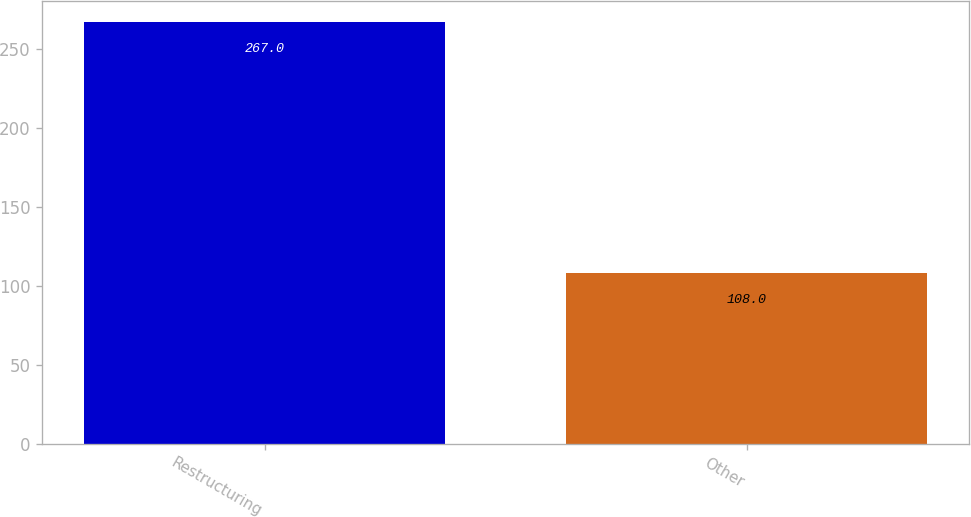Convert chart to OTSL. <chart><loc_0><loc_0><loc_500><loc_500><bar_chart><fcel>Restructuring<fcel>Other<nl><fcel>267<fcel>108<nl></chart> 